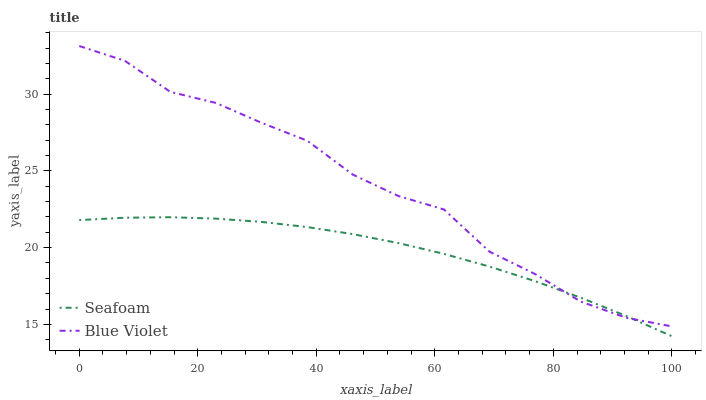Does Blue Violet have the minimum area under the curve?
Answer yes or no. No. Is Blue Violet the smoothest?
Answer yes or no. No. Does Blue Violet have the lowest value?
Answer yes or no. No. 